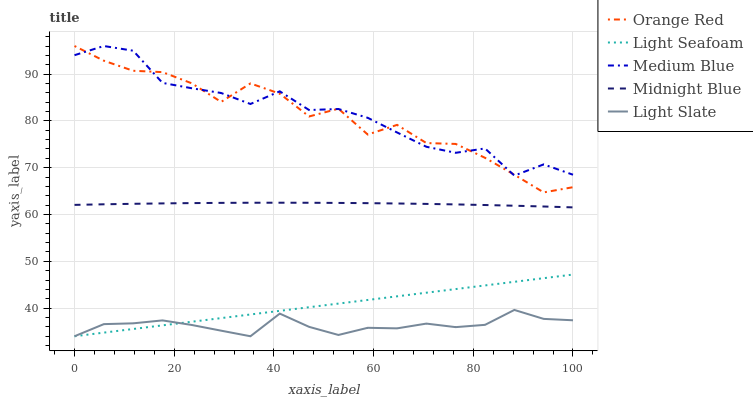Does Light Seafoam have the minimum area under the curve?
Answer yes or no. No. Does Light Seafoam have the maximum area under the curve?
Answer yes or no. No. Is Medium Blue the smoothest?
Answer yes or no. No. Is Medium Blue the roughest?
Answer yes or no. No. Does Medium Blue have the lowest value?
Answer yes or no. No. Does Light Seafoam have the highest value?
Answer yes or no. No. Is Light Seafoam less than Medium Blue?
Answer yes or no. Yes. Is Medium Blue greater than Midnight Blue?
Answer yes or no. Yes. Does Light Seafoam intersect Medium Blue?
Answer yes or no. No. 